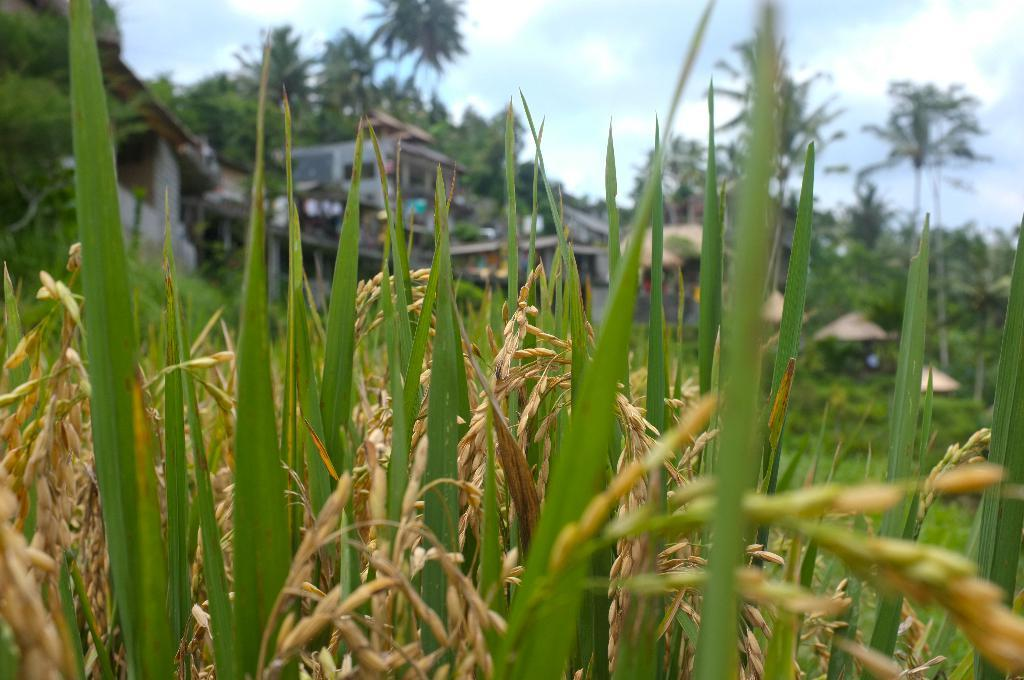What type of plants can be seen in the image? There are paddy plants in the image. What other natural elements are present in the image? There are trees in the image. What type of human-made structures can be seen in the image? There are houses in the image. What is visible in the background of the image? The sky is visible in the image. What can be observed in the sky? Clouds are present in the sky. How many lips can be seen in the image? There are no lips present in the image. What is the fifth element in the image? The provided facts do not indicate a specific order or numbering of elements in the image, so it is not possible to determine a fifth element. 